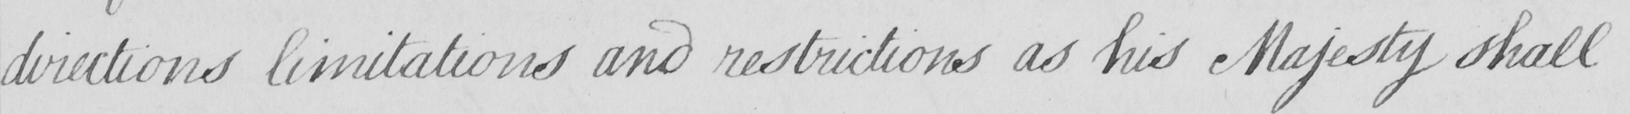What does this handwritten line say? directions limitations and restrictions as his Majesty shall 